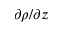<formula> <loc_0><loc_0><loc_500><loc_500>\partial \rho / \partial z</formula> 